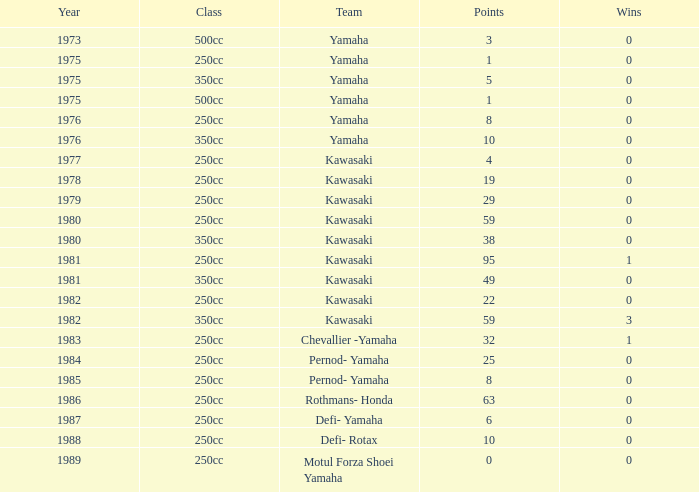Prior to 1978, how many points did the yamaha 250cc class team accumulate, with at least one win? 0.0. Would you be able to parse every entry in this table? {'header': ['Year', 'Class', 'Team', 'Points', 'Wins'], 'rows': [['1973', '500cc', 'Yamaha', '3', '0'], ['1975', '250cc', 'Yamaha', '1', '0'], ['1975', '350cc', 'Yamaha', '5', '0'], ['1975', '500cc', 'Yamaha', '1', '0'], ['1976', '250cc', 'Yamaha', '8', '0'], ['1976', '350cc', 'Yamaha', '10', '0'], ['1977', '250cc', 'Kawasaki', '4', '0'], ['1978', '250cc', 'Kawasaki', '19', '0'], ['1979', '250cc', 'Kawasaki', '29', '0'], ['1980', '250cc', 'Kawasaki', '59', '0'], ['1980', '350cc', 'Kawasaki', '38', '0'], ['1981', '250cc', 'Kawasaki', '95', '1'], ['1981', '350cc', 'Kawasaki', '49', '0'], ['1982', '250cc', 'Kawasaki', '22', '0'], ['1982', '350cc', 'Kawasaki', '59', '3'], ['1983', '250cc', 'Chevallier -Yamaha', '32', '1'], ['1984', '250cc', 'Pernod- Yamaha', '25', '0'], ['1985', '250cc', 'Pernod- Yamaha', '8', '0'], ['1986', '250cc', 'Rothmans- Honda', '63', '0'], ['1987', '250cc', 'Defi- Yamaha', '6', '0'], ['1988', '250cc', 'Defi- Rotax', '10', '0'], ['1989', '250cc', 'Motul Forza Shoei Yamaha', '0', '0']]} 